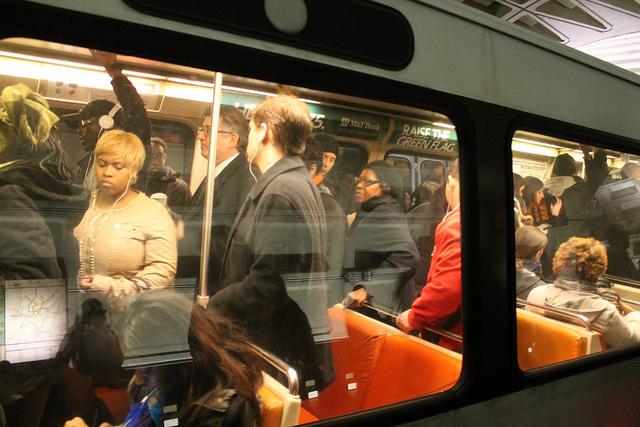Why are people standing?
Write a very short answer. Crowded. Is the bus crowded?
Quick response, please. Yes. What color are the seats?
Keep it brief. Orange. 